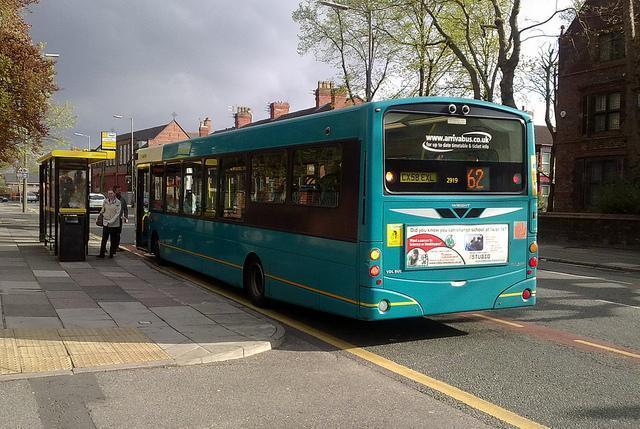How many levels does this bus have?
Give a very brief answer. 1. How many buses are there?
Give a very brief answer. 1. How many giraffe heads can you see?
Give a very brief answer. 0. 